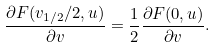Convert formula to latex. <formula><loc_0><loc_0><loc_500><loc_500>\frac { \partial F ( v _ { 1 / 2 } / 2 , u ) } { \partial v } = \frac { 1 } { 2 } \frac { \partial F ( 0 , u ) } { \partial v } .</formula> 